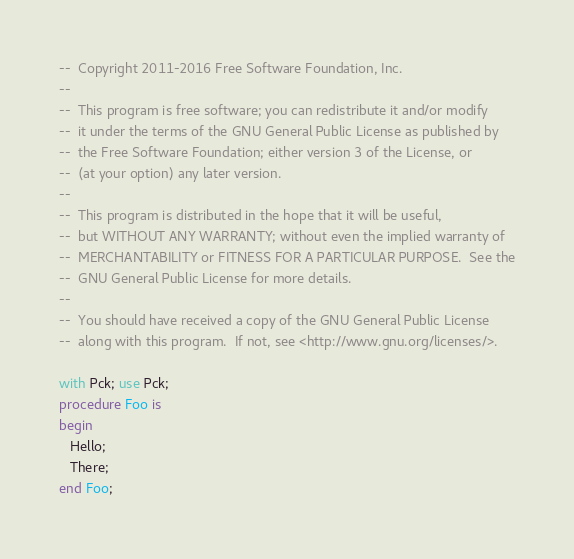<code> <loc_0><loc_0><loc_500><loc_500><_Ada_>--  Copyright 2011-2016 Free Software Foundation, Inc.
--
--  This program is free software; you can redistribute it and/or modify
--  it under the terms of the GNU General Public License as published by
--  the Free Software Foundation; either version 3 of the License, or
--  (at your option) any later version.
--
--  This program is distributed in the hope that it will be useful,
--  but WITHOUT ANY WARRANTY; without even the implied warranty of
--  MERCHANTABILITY or FITNESS FOR A PARTICULAR PURPOSE.  See the
--  GNU General Public License for more details.
--
--  You should have received a copy of the GNU General Public License
--  along with this program.  If not, see <http://www.gnu.org/licenses/>.

with Pck; use Pck;
procedure Foo is
begin
   Hello;
   There;
end Foo;
</code> 